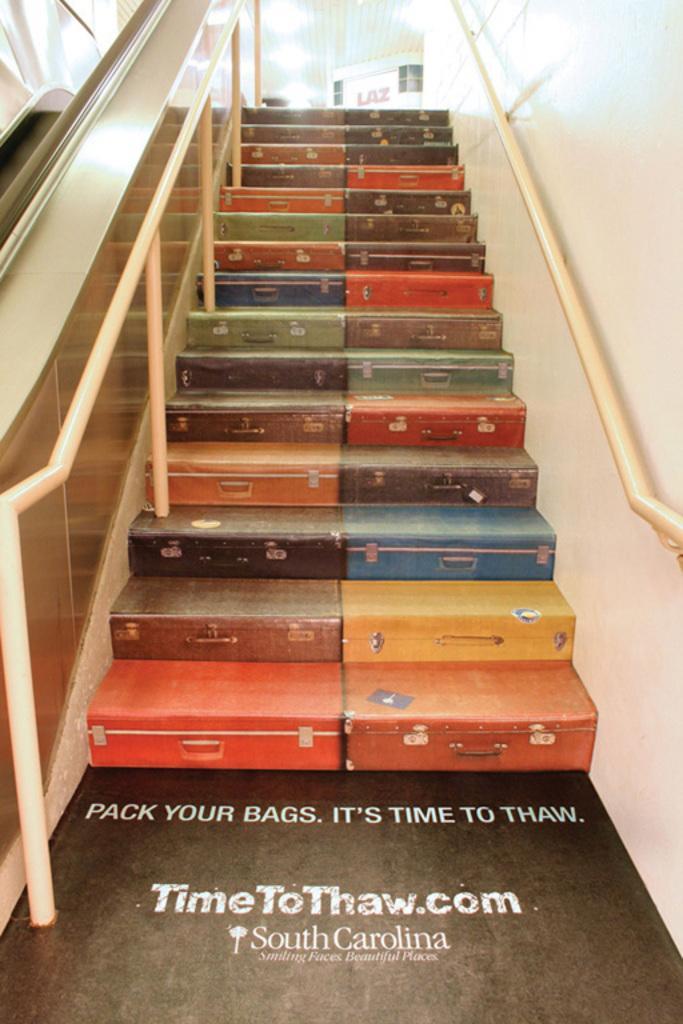Describe this image in one or two sentences. In this image in the center there are some suitcases, and on the right side there is wall and on the left side it looks like a railing and poles. And at the top of the image there are some objects and lights, and at the bottom there is text. 